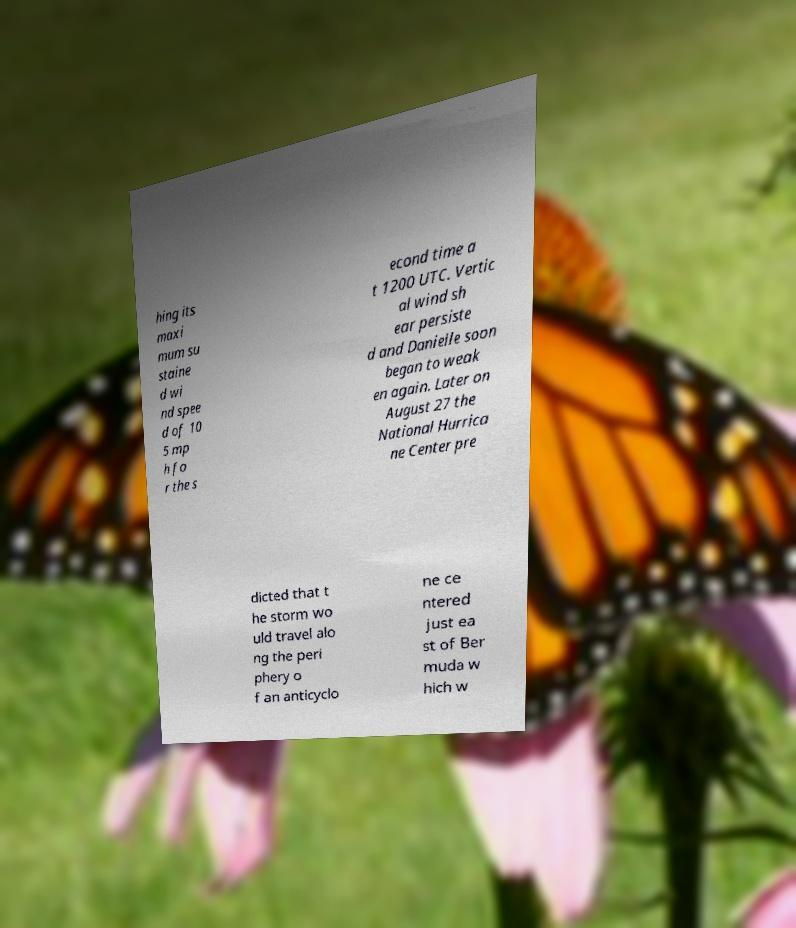There's text embedded in this image that I need extracted. Can you transcribe it verbatim? hing its maxi mum su staine d wi nd spee d of 10 5 mp h fo r the s econd time a t 1200 UTC. Vertic al wind sh ear persiste d and Danielle soon began to weak en again. Later on August 27 the National Hurrica ne Center pre dicted that t he storm wo uld travel alo ng the peri phery o f an anticyclo ne ce ntered just ea st of Ber muda w hich w 